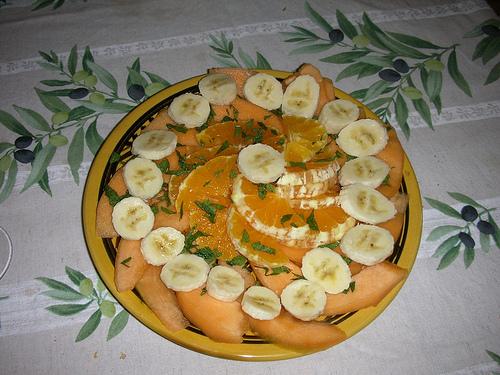What color is the tablecloth?
Quick response, please. White. What is on the dish?
Answer briefly. Fruit. What design is on the tablecloth?
Be succinct. Leaves. What does the sliced peach colored fruit along the outside of the plate grow on?
Keep it brief. Vine. 